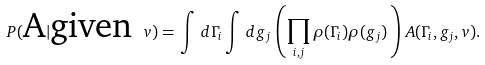<formula> <loc_0><loc_0><loc_500><loc_500>P ( \text {A} | \text {given } v ) = \, \int \, d \Gamma _ { i } \int \, d g _ { j } \, \left ( \prod _ { i , j } \rho ( \Gamma _ { i } ) \rho ( g _ { j } ) \, \right ) \, A ( \Gamma _ { i } , g _ { j } , v ) .</formula> 